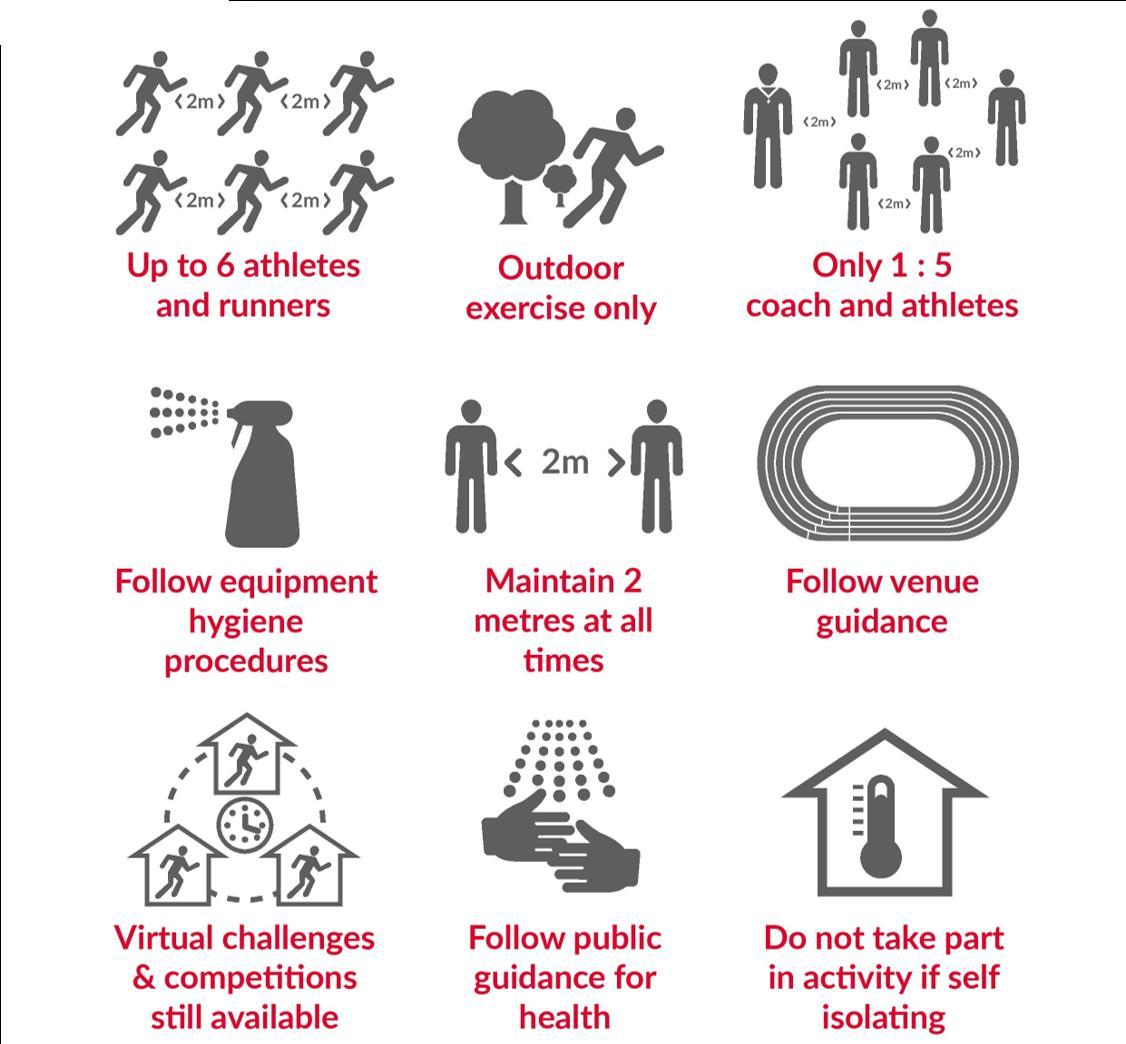what distance should be maintained ?
Answer the question with a short phrase. 2 metres What exercises are allowed? outdoor Which activities are still available? virtual challenges & competitions in which situation should you not participate in any activity? if self isolating How many athletes allowed for one coach? 5 